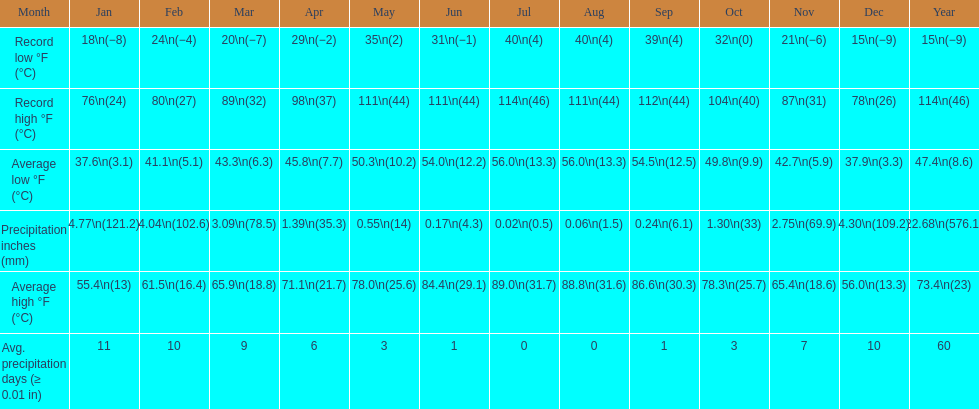How many months had a record high of 111 degrees? 3. Would you mind parsing the complete table? {'header': ['Month', 'Jan', 'Feb', 'Mar', 'Apr', 'May', 'Jun', 'Jul', 'Aug', 'Sep', 'Oct', 'Nov', 'Dec', 'Year'], 'rows': [['Record low °F (°C)', '18\\n(−8)', '24\\n(−4)', '20\\n(−7)', '29\\n(−2)', '35\\n(2)', '31\\n(−1)', '40\\n(4)', '40\\n(4)', '39\\n(4)', '32\\n(0)', '21\\n(−6)', '15\\n(−9)', '15\\n(−9)'], ['Record high °F (°C)', '76\\n(24)', '80\\n(27)', '89\\n(32)', '98\\n(37)', '111\\n(44)', '111\\n(44)', '114\\n(46)', '111\\n(44)', '112\\n(44)', '104\\n(40)', '87\\n(31)', '78\\n(26)', '114\\n(46)'], ['Average low °F (°C)', '37.6\\n(3.1)', '41.1\\n(5.1)', '43.3\\n(6.3)', '45.8\\n(7.7)', '50.3\\n(10.2)', '54.0\\n(12.2)', '56.0\\n(13.3)', '56.0\\n(13.3)', '54.5\\n(12.5)', '49.8\\n(9.9)', '42.7\\n(5.9)', '37.9\\n(3.3)', '47.4\\n(8.6)'], ['Precipitation inches (mm)', '4.77\\n(121.2)', '4.04\\n(102.6)', '3.09\\n(78.5)', '1.39\\n(35.3)', '0.55\\n(14)', '0.17\\n(4.3)', '0.02\\n(0.5)', '0.06\\n(1.5)', '0.24\\n(6.1)', '1.30\\n(33)', '2.75\\n(69.9)', '4.30\\n(109.2)', '22.68\\n(576.1)'], ['Average high °F (°C)', '55.4\\n(13)', '61.5\\n(16.4)', '65.9\\n(18.8)', '71.1\\n(21.7)', '78.0\\n(25.6)', '84.4\\n(29.1)', '89.0\\n(31.7)', '88.8\\n(31.6)', '86.6\\n(30.3)', '78.3\\n(25.7)', '65.4\\n(18.6)', '56.0\\n(13.3)', '73.4\\n(23)'], ['Avg. precipitation days (≥ 0.01 in)', '11', '10', '9', '6', '3', '1', '0', '0', '1', '3', '7', '10', '60']]} 